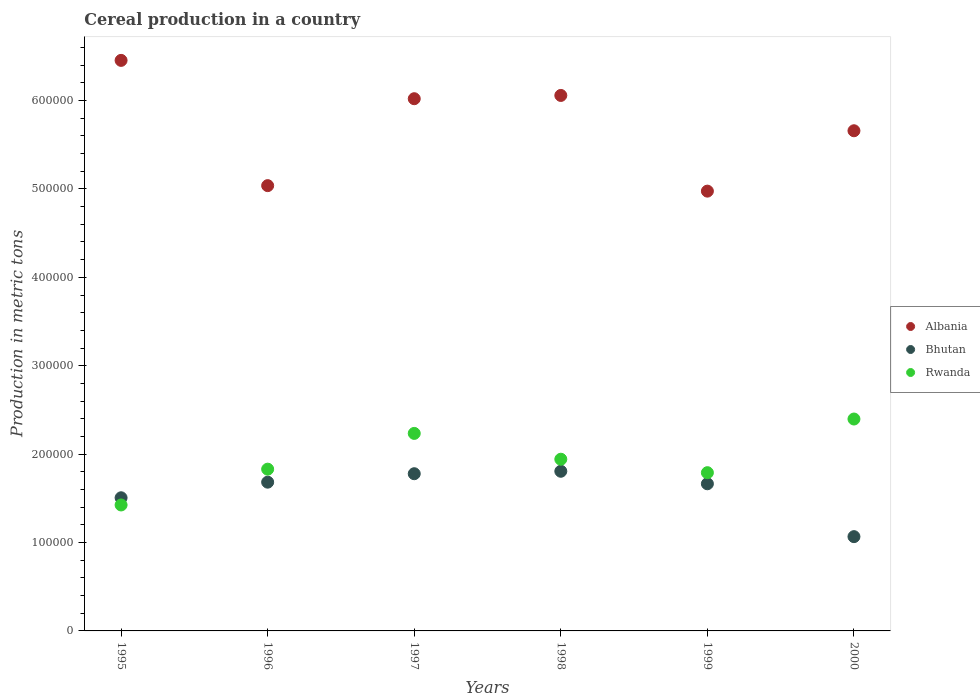What is the total cereal production in Bhutan in 1999?
Your answer should be very brief. 1.66e+05. Across all years, what is the maximum total cereal production in Rwanda?
Your response must be concise. 2.40e+05. Across all years, what is the minimum total cereal production in Bhutan?
Provide a short and direct response. 1.07e+05. In which year was the total cereal production in Bhutan minimum?
Keep it short and to the point. 2000. What is the total total cereal production in Bhutan in the graph?
Keep it short and to the point. 9.50e+05. What is the difference between the total cereal production in Rwanda in 1995 and that in 1998?
Offer a very short reply. -5.17e+04. What is the difference between the total cereal production in Albania in 1998 and the total cereal production in Rwanda in 1999?
Give a very brief answer. 4.27e+05. What is the average total cereal production in Albania per year?
Make the answer very short. 5.70e+05. In the year 1999, what is the difference between the total cereal production in Albania and total cereal production in Rwanda?
Make the answer very short. 3.18e+05. In how many years, is the total cereal production in Albania greater than 20000 metric tons?
Make the answer very short. 6. What is the ratio of the total cereal production in Albania in 1995 to that in 1997?
Offer a terse response. 1.07. What is the difference between the highest and the second highest total cereal production in Rwanda?
Your response must be concise. 1.63e+04. What is the difference between the highest and the lowest total cereal production in Rwanda?
Your response must be concise. 9.72e+04. In how many years, is the total cereal production in Rwanda greater than the average total cereal production in Rwanda taken over all years?
Offer a very short reply. 3. Does the total cereal production in Bhutan monotonically increase over the years?
Your answer should be very brief. No. Is the total cereal production in Rwanda strictly greater than the total cereal production in Albania over the years?
Your answer should be very brief. No. Is the total cereal production in Bhutan strictly less than the total cereal production in Albania over the years?
Provide a succinct answer. Yes. How many dotlines are there?
Make the answer very short. 3. How many years are there in the graph?
Ensure brevity in your answer.  6. What is the difference between two consecutive major ticks on the Y-axis?
Give a very brief answer. 1.00e+05. Are the values on the major ticks of Y-axis written in scientific E-notation?
Give a very brief answer. No. Does the graph contain grids?
Offer a terse response. No. Where does the legend appear in the graph?
Keep it short and to the point. Center right. How many legend labels are there?
Your answer should be very brief. 3. What is the title of the graph?
Ensure brevity in your answer.  Cereal production in a country. Does "High income: nonOECD" appear as one of the legend labels in the graph?
Keep it short and to the point. No. What is the label or title of the X-axis?
Your answer should be very brief. Years. What is the label or title of the Y-axis?
Make the answer very short. Production in metric tons. What is the Production in metric tons in Albania in 1995?
Make the answer very short. 6.45e+05. What is the Production in metric tons of Bhutan in 1995?
Keep it short and to the point. 1.51e+05. What is the Production in metric tons in Rwanda in 1995?
Your answer should be very brief. 1.42e+05. What is the Production in metric tons in Albania in 1996?
Provide a succinct answer. 5.04e+05. What is the Production in metric tons of Bhutan in 1996?
Offer a very short reply. 1.68e+05. What is the Production in metric tons of Rwanda in 1996?
Make the answer very short. 1.83e+05. What is the Production in metric tons of Albania in 1997?
Provide a short and direct response. 6.02e+05. What is the Production in metric tons of Bhutan in 1997?
Ensure brevity in your answer.  1.78e+05. What is the Production in metric tons in Rwanda in 1997?
Your answer should be compact. 2.23e+05. What is the Production in metric tons in Albania in 1998?
Ensure brevity in your answer.  6.06e+05. What is the Production in metric tons in Bhutan in 1998?
Provide a succinct answer. 1.81e+05. What is the Production in metric tons of Rwanda in 1998?
Make the answer very short. 1.94e+05. What is the Production in metric tons of Albania in 1999?
Keep it short and to the point. 4.98e+05. What is the Production in metric tons of Bhutan in 1999?
Provide a succinct answer. 1.66e+05. What is the Production in metric tons in Rwanda in 1999?
Make the answer very short. 1.79e+05. What is the Production in metric tons of Albania in 2000?
Provide a short and direct response. 5.66e+05. What is the Production in metric tons in Bhutan in 2000?
Your response must be concise. 1.07e+05. What is the Production in metric tons in Rwanda in 2000?
Your response must be concise. 2.40e+05. Across all years, what is the maximum Production in metric tons of Albania?
Provide a succinct answer. 6.45e+05. Across all years, what is the maximum Production in metric tons in Bhutan?
Offer a very short reply. 1.81e+05. Across all years, what is the maximum Production in metric tons of Rwanda?
Give a very brief answer. 2.40e+05. Across all years, what is the minimum Production in metric tons in Albania?
Offer a very short reply. 4.98e+05. Across all years, what is the minimum Production in metric tons in Bhutan?
Your response must be concise. 1.07e+05. Across all years, what is the minimum Production in metric tons of Rwanda?
Offer a terse response. 1.42e+05. What is the total Production in metric tons of Albania in the graph?
Your answer should be very brief. 3.42e+06. What is the total Production in metric tons in Bhutan in the graph?
Keep it short and to the point. 9.50e+05. What is the total Production in metric tons in Rwanda in the graph?
Your answer should be very brief. 1.16e+06. What is the difference between the Production in metric tons of Albania in 1995 and that in 1996?
Keep it short and to the point. 1.42e+05. What is the difference between the Production in metric tons of Bhutan in 1995 and that in 1996?
Offer a terse response. -1.76e+04. What is the difference between the Production in metric tons in Rwanda in 1995 and that in 1996?
Your response must be concise. -4.05e+04. What is the difference between the Production in metric tons in Albania in 1995 and that in 1997?
Your response must be concise. 4.34e+04. What is the difference between the Production in metric tons of Bhutan in 1995 and that in 1997?
Give a very brief answer. -2.72e+04. What is the difference between the Production in metric tons in Rwanda in 1995 and that in 1997?
Offer a terse response. -8.10e+04. What is the difference between the Production in metric tons of Albania in 1995 and that in 1998?
Offer a very short reply. 3.97e+04. What is the difference between the Production in metric tons in Bhutan in 1995 and that in 1998?
Give a very brief answer. -3.00e+04. What is the difference between the Production in metric tons of Rwanda in 1995 and that in 1998?
Offer a very short reply. -5.17e+04. What is the difference between the Production in metric tons of Albania in 1995 and that in 1999?
Make the answer very short. 1.48e+05. What is the difference between the Production in metric tons in Bhutan in 1995 and that in 1999?
Give a very brief answer. -1.58e+04. What is the difference between the Production in metric tons of Rwanda in 1995 and that in 1999?
Keep it short and to the point. -3.65e+04. What is the difference between the Production in metric tons of Albania in 1995 and that in 2000?
Provide a short and direct response. 7.96e+04. What is the difference between the Production in metric tons of Bhutan in 1995 and that in 2000?
Your answer should be compact. 4.40e+04. What is the difference between the Production in metric tons of Rwanda in 1995 and that in 2000?
Your answer should be compact. -9.72e+04. What is the difference between the Production in metric tons in Albania in 1996 and that in 1997?
Offer a terse response. -9.83e+04. What is the difference between the Production in metric tons in Bhutan in 1996 and that in 1997?
Offer a very short reply. -9560. What is the difference between the Production in metric tons of Rwanda in 1996 and that in 1997?
Keep it short and to the point. -4.05e+04. What is the difference between the Production in metric tons of Albania in 1996 and that in 1998?
Give a very brief answer. -1.02e+05. What is the difference between the Production in metric tons in Bhutan in 1996 and that in 1998?
Make the answer very short. -1.23e+04. What is the difference between the Production in metric tons of Rwanda in 1996 and that in 1998?
Give a very brief answer. -1.12e+04. What is the difference between the Production in metric tons of Albania in 1996 and that in 1999?
Your answer should be very brief. 6214. What is the difference between the Production in metric tons of Bhutan in 1996 and that in 1999?
Offer a terse response. 1817. What is the difference between the Production in metric tons of Rwanda in 1996 and that in 1999?
Your answer should be compact. 3975. What is the difference between the Production in metric tons of Albania in 1996 and that in 2000?
Offer a terse response. -6.21e+04. What is the difference between the Production in metric tons of Bhutan in 1996 and that in 2000?
Your answer should be compact. 6.16e+04. What is the difference between the Production in metric tons of Rwanda in 1996 and that in 2000?
Your answer should be compact. -5.67e+04. What is the difference between the Production in metric tons of Albania in 1997 and that in 1998?
Give a very brief answer. -3703. What is the difference between the Production in metric tons in Bhutan in 1997 and that in 1998?
Make the answer very short. -2772. What is the difference between the Production in metric tons in Rwanda in 1997 and that in 1998?
Offer a terse response. 2.92e+04. What is the difference between the Production in metric tons of Albania in 1997 and that in 1999?
Offer a very short reply. 1.05e+05. What is the difference between the Production in metric tons in Bhutan in 1997 and that in 1999?
Your response must be concise. 1.14e+04. What is the difference between the Production in metric tons of Rwanda in 1997 and that in 1999?
Provide a succinct answer. 4.44e+04. What is the difference between the Production in metric tons in Albania in 1997 and that in 2000?
Ensure brevity in your answer.  3.62e+04. What is the difference between the Production in metric tons in Bhutan in 1997 and that in 2000?
Give a very brief answer. 7.12e+04. What is the difference between the Production in metric tons in Rwanda in 1997 and that in 2000?
Make the answer very short. -1.63e+04. What is the difference between the Production in metric tons in Albania in 1998 and that in 1999?
Provide a short and direct response. 1.08e+05. What is the difference between the Production in metric tons of Bhutan in 1998 and that in 1999?
Your answer should be very brief. 1.41e+04. What is the difference between the Production in metric tons in Rwanda in 1998 and that in 1999?
Ensure brevity in your answer.  1.52e+04. What is the difference between the Production in metric tons of Albania in 1998 and that in 2000?
Provide a short and direct response. 3.99e+04. What is the difference between the Production in metric tons in Bhutan in 1998 and that in 2000?
Your response must be concise. 7.40e+04. What is the difference between the Production in metric tons in Rwanda in 1998 and that in 2000?
Your response must be concise. -4.55e+04. What is the difference between the Production in metric tons of Albania in 1999 and that in 2000?
Ensure brevity in your answer.  -6.83e+04. What is the difference between the Production in metric tons of Bhutan in 1999 and that in 2000?
Ensure brevity in your answer.  5.98e+04. What is the difference between the Production in metric tons of Rwanda in 1999 and that in 2000?
Keep it short and to the point. -6.07e+04. What is the difference between the Production in metric tons in Albania in 1995 and the Production in metric tons in Bhutan in 1996?
Offer a terse response. 4.77e+05. What is the difference between the Production in metric tons in Albania in 1995 and the Production in metric tons in Rwanda in 1996?
Your answer should be very brief. 4.62e+05. What is the difference between the Production in metric tons of Bhutan in 1995 and the Production in metric tons of Rwanda in 1996?
Ensure brevity in your answer.  -3.24e+04. What is the difference between the Production in metric tons in Albania in 1995 and the Production in metric tons in Bhutan in 1997?
Offer a terse response. 4.68e+05. What is the difference between the Production in metric tons of Albania in 1995 and the Production in metric tons of Rwanda in 1997?
Offer a terse response. 4.22e+05. What is the difference between the Production in metric tons in Bhutan in 1995 and the Production in metric tons in Rwanda in 1997?
Keep it short and to the point. -7.28e+04. What is the difference between the Production in metric tons of Albania in 1995 and the Production in metric tons of Bhutan in 1998?
Your answer should be very brief. 4.65e+05. What is the difference between the Production in metric tons of Albania in 1995 and the Production in metric tons of Rwanda in 1998?
Your answer should be compact. 4.51e+05. What is the difference between the Production in metric tons in Bhutan in 1995 and the Production in metric tons in Rwanda in 1998?
Offer a very short reply. -4.36e+04. What is the difference between the Production in metric tons in Albania in 1995 and the Production in metric tons in Bhutan in 1999?
Provide a short and direct response. 4.79e+05. What is the difference between the Production in metric tons of Albania in 1995 and the Production in metric tons of Rwanda in 1999?
Give a very brief answer. 4.66e+05. What is the difference between the Production in metric tons in Bhutan in 1995 and the Production in metric tons in Rwanda in 1999?
Make the answer very short. -2.84e+04. What is the difference between the Production in metric tons of Albania in 1995 and the Production in metric tons of Bhutan in 2000?
Make the answer very short. 5.39e+05. What is the difference between the Production in metric tons in Albania in 1995 and the Production in metric tons in Rwanda in 2000?
Provide a succinct answer. 4.06e+05. What is the difference between the Production in metric tons in Bhutan in 1995 and the Production in metric tons in Rwanda in 2000?
Ensure brevity in your answer.  -8.91e+04. What is the difference between the Production in metric tons in Albania in 1996 and the Production in metric tons in Bhutan in 1997?
Your response must be concise. 3.26e+05. What is the difference between the Production in metric tons in Albania in 1996 and the Production in metric tons in Rwanda in 1997?
Give a very brief answer. 2.80e+05. What is the difference between the Production in metric tons of Bhutan in 1996 and the Production in metric tons of Rwanda in 1997?
Make the answer very short. -5.52e+04. What is the difference between the Production in metric tons of Albania in 1996 and the Production in metric tons of Bhutan in 1998?
Offer a very short reply. 3.23e+05. What is the difference between the Production in metric tons in Albania in 1996 and the Production in metric tons in Rwanda in 1998?
Provide a succinct answer. 3.09e+05. What is the difference between the Production in metric tons of Bhutan in 1996 and the Production in metric tons of Rwanda in 1998?
Your response must be concise. -2.60e+04. What is the difference between the Production in metric tons in Albania in 1996 and the Production in metric tons in Bhutan in 1999?
Offer a terse response. 3.37e+05. What is the difference between the Production in metric tons in Albania in 1996 and the Production in metric tons in Rwanda in 1999?
Make the answer very short. 3.25e+05. What is the difference between the Production in metric tons in Bhutan in 1996 and the Production in metric tons in Rwanda in 1999?
Your answer should be very brief. -1.07e+04. What is the difference between the Production in metric tons in Albania in 1996 and the Production in metric tons in Bhutan in 2000?
Your response must be concise. 3.97e+05. What is the difference between the Production in metric tons of Albania in 1996 and the Production in metric tons of Rwanda in 2000?
Make the answer very short. 2.64e+05. What is the difference between the Production in metric tons of Bhutan in 1996 and the Production in metric tons of Rwanda in 2000?
Your response must be concise. -7.14e+04. What is the difference between the Production in metric tons in Albania in 1997 and the Production in metric tons in Bhutan in 1998?
Provide a succinct answer. 4.21e+05. What is the difference between the Production in metric tons of Albania in 1997 and the Production in metric tons of Rwanda in 1998?
Provide a succinct answer. 4.08e+05. What is the difference between the Production in metric tons in Bhutan in 1997 and the Production in metric tons in Rwanda in 1998?
Your answer should be very brief. -1.64e+04. What is the difference between the Production in metric tons of Albania in 1997 and the Production in metric tons of Bhutan in 1999?
Make the answer very short. 4.36e+05. What is the difference between the Production in metric tons of Albania in 1997 and the Production in metric tons of Rwanda in 1999?
Your response must be concise. 4.23e+05. What is the difference between the Production in metric tons in Bhutan in 1997 and the Production in metric tons in Rwanda in 1999?
Offer a terse response. -1173. What is the difference between the Production in metric tons in Albania in 1997 and the Production in metric tons in Bhutan in 2000?
Ensure brevity in your answer.  4.95e+05. What is the difference between the Production in metric tons of Albania in 1997 and the Production in metric tons of Rwanda in 2000?
Make the answer very short. 3.62e+05. What is the difference between the Production in metric tons in Bhutan in 1997 and the Production in metric tons in Rwanda in 2000?
Offer a very short reply. -6.19e+04. What is the difference between the Production in metric tons in Albania in 1998 and the Production in metric tons in Bhutan in 1999?
Your answer should be very brief. 4.39e+05. What is the difference between the Production in metric tons of Albania in 1998 and the Production in metric tons of Rwanda in 1999?
Give a very brief answer. 4.27e+05. What is the difference between the Production in metric tons in Bhutan in 1998 and the Production in metric tons in Rwanda in 1999?
Offer a very short reply. 1599. What is the difference between the Production in metric tons in Albania in 1998 and the Production in metric tons in Bhutan in 2000?
Your answer should be very brief. 4.99e+05. What is the difference between the Production in metric tons of Albania in 1998 and the Production in metric tons of Rwanda in 2000?
Offer a very short reply. 3.66e+05. What is the difference between the Production in metric tons in Bhutan in 1998 and the Production in metric tons in Rwanda in 2000?
Your response must be concise. -5.91e+04. What is the difference between the Production in metric tons of Albania in 1999 and the Production in metric tons of Bhutan in 2000?
Provide a succinct answer. 3.91e+05. What is the difference between the Production in metric tons in Albania in 1999 and the Production in metric tons in Rwanda in 2000?
Your response must be concise. 2.58e+05. What is the difference between the Production in metric tons of Bhutan in 1999 and the Production in metric tons of Rwanda in 2000?
Keep it short and to the point. -7.33e+04. What is the average Production in metric tons in Albania per year?
Give a very brief answer. 5.70e+05. What is the average Production in metric tons of Bhutan per year?
Your response must be concise. 1.58e+05. What is the average Production in metric tons of Rwanda per year?
Offer a terse response. 1.94e+05. In the year 1995, what is the difference between the Production in metric tons in Albania and Production in metric tons in Bhutan?
Provide a succinct answer. 4.95e+05. In the year 1995, what is the difference between the Production in metric tons of Albania and Production in metric tons of Rwanda?
Make the answer very short. 5.03e+05. In the year 1995, what is the difference between the Production in metric tons in Bhutan and Production in metric tons in Rwanda?
Your answer should be very brief. 8140. In the year 1996, what is the difference between the Production in metric tons in Albania and Production in metric tons in Bhutan?
Offer a very short reply. 3.35e+05. In the year 1996, what is the difference between the Production in metric tons in Albania and Production in metric tons in Rwanda?
Keep it short and to the point. 3.21e+05. In the year 1996, what is the difference between the Production in metric tons in Bhutan and Production in metric tons in Rwanda?
Provide a succinct answer. -1.47e+04. In the year 1997, what is the difference between the Production in metric tons of Albania and Production in metric tons of Bhutan?
Give a very brief answer. 4.24e+05. In the year 1997, what is the difference between the Production in metric tons in Albania and Production in metric tons in Rwanda?
Your answer should be compact. 3.79e+05. In the year 1997, what is the difference between the Production in metric tons in Bhutan and Production in metric tons in Rwanda?
Provide a succinct answer. -4.56e+04. In the year 1998, what is the difference between the Production in metric tons of Albania and Production in metric tons of Bhutan?
Keep it short and to the point. 4.25e+05. In the year 1998, what is the difference between the Production in metric tons of Albania and Production in metric tons of Rwanda?
Provide a short and direct response. 4.12e+05. In the year 1998, what is the difference between the Production in metric tons in Bhutan and Production in metric tons in Rwanda?
Ensure brevity in your answer.  -1.36e+04. In the year 1999, what is the difference between the Production in metric tons of Albania and Production in metric tons of Bhutan?
Your response must be concise. 3.31e+05. In the year 1999, what is the difference between the Production in metric tons in Albania and Production in metric tons in Rwanda?
Your answer should be compact. 3.18e+05. In the year 1999, what is the difference between the Production in metric tons of Bhutan and Production in metric tons of Rwanda?
Give a very brief answer. -1.26e+04. In the year 2000, what is the difference between the Production in metric tons in Albania and Production in metric tons in Bhutan?
Give a very brief answer. 4.59e+05. In the year 2000, what is the difference between the Production in metric tons of Albania and Production in metric tons of Rwanda?
Keep it short and to the point. 3.26e+05. In the year 2000, what is the difference between the Production in metric tons in Bhutan and Production in metric tons in Rwanda?
Keep it short and to the point. -1.33e+05. What is the ratio of the Production in metric tons of Albania in 1995 to that in 1996?
Provide a succinct answer. 1.28. What is the ratio of the Production in metric tons in Bhutan in 1995 to that in 1996?
Make the answer very short. 0.9. What is the ratio of the Production in metric tons of Rwanda in 1995 to that in 1996?
Your answer should be compact. 0.78. What is the ratio of the Production in metric tons of Albania in 1995 to that in 1997?
Your answer should be very brief. 1.07. What is the ratio of the Production in metric tons in Bhutan in 1995 to that in 1997?
Your response must be concise. 0.85. What is the ratio of the Production in metric tons in Rwanda in 1995 to that in 1997?
Your answer should be very brief. 0.64. What is the ratio of the Production in metric tons of Albania in 1995 to that in 1998?
Your response must be concise. 1.07. What is the ratio of the Production in metric tons of Bhutan in 1995 to that in 1998?
Provide a short and direct response. 0.83. What is the ratio of the Production in metric tons of Rwanda in 1995 to that in 1998?
Offer a very short reply. 0.73. What is the ratio of the Production in metric tons in Albania in 1995 to that in 1999?
Your answer should be compact. 1.3. What is the ratio of the Production in metric tons in Bhutan in 1995 to that in 1999?
Provide a short and direct response. 0.9. What is the ratio of the Production in metric tons in Rwanda in 1995 to that in 1999?
Your response must be concise. 0.8. What is the ratio of the Production in metric tons of Albania in 1995 to that in 2000?
Offer a terse response. 1.14. What is the ratio of the Production in metric tons of Bhutan in 1995 to that in 2000?
Offer a very short reply. 1.41. What is the ratio of the Production in metric tons of Rwanda in 1995 to that in 2000?
Provide a succinct answer. 0.59. What is the ratio of the Production in metric tons of Albania in 1996 to that in 1997?
Make the answer very short. 0.84. What is the ratio of the Production in metric tons in Bhutan in 1996 to that in 1997?
Offer a very short reply. 0.95. What is the ratio of the Production in metric tons in Rwanda in 1996 to that in 1997?
Your answer should be very brief. 0.82. What is the ratio of the Production in metric tons of Albania in 1996 to that in 1998?
Your answer should be very brief. 0.83. What is the ratio of the Production in metric tons of Bhutan in 1996 to that in 1998?
Ensure brevity in your answer.  0.93. What is the ratio of the Production in metric tons of Rwanda in 1996 to that in 1998?
Keep it short and to the point. 0.94. What is the ratio of the Production in metric tons in Albania in 1996 to that in 1999?
Ensure brevity in your answer.  1.01. What is the ratio of the Production in metric tons in Bhutan in 1996 to that in 1999?
Provide a short and direct response. 1.01. What is the ratio of the Production in metric tons of Rwanda in 1996 to that in 1999?
Provide a short and direct response. 1.02. What is the ratio of the Production in metric tons of Albania in 1996 to that in 2000?
Give a very brief answer. 0.89. What is the ratio of the Production in metric tons of Bhutan in 1996 to that in 2000?
Your answer should be compact. 1.58. What is the ratio of the Production in metric tons of Rwanda in 1996 to that in 2000?
Your answer should be compact. 0.76. What is the ratio of the Production in metric tons of Bhutan in 1997 to that in 1998?
Offer a very short reply. 0.98. What is the ratio of the Production in metric tons in Rwanda in 1997 to that in 1998?
Ensure brevity in your answer.  1.15. What is the ratio of the Production in metric tons in Albania in 1997 to that in 1999?
Give a very brief answer. 1.21. What is the ratio of the Production in metric tons of Bhutan in 1997 to that in 1999?
Keep it short and to the point. 1.07. What is the ratio of the Production in metric tons of Rwanda in 1997 to that in 1999?
Your response must be concise. 1.25. What is the ratio of the Production in metric tons of Albania in 1997 to that in 2000?
Your answer should be very brief. 1.06. What is the ratio of the Production in metric tons in Bhutan in 1997 to that in 2000?
Provide a succinct answer. 1.67. What is the ratio of the Production in metric tons in Rwanda in 1997 to that in 2000?
Your answer should be compact. 0.93. What is the ratio of the Production in metric tons of Albania in 1998 to that in 1999?
Provide a succinct answer. 1.22. What is the ratio of the Production in metric tons of Bhutan in 1998 to that in 1999?
Keep it short and to the point. 1.08. What is the ratio of the Production in metric tons of Rwanda in 1998 to that in 1999?
Keep it short and to the point. 1.08. What is the ratio of the Production in metric tons in Albania in 1998 to that in 2000?
Provide a short and direct response. 1.07. What is the ratio of the Production in metric tons in Bhutan in 1998 to that in 2000?
Your answer should be very brief. 1.69. What is the ratio of the Production in metric tons in Rwanda in 1998 to that in 2000?
Ensure brevity in your answer.  0.81. What is the ratio of the Production in metric tons in Albania in 1999 to that in 2000?
Your answer should be very brief. 0.88. What is the ratio of the Production in metric tons in Bhutan in 1999 to that in 2000?
Give a very brief answer. 1.56. What is the ratio of the Production in metric tons in Rwanda in 1999 to that in 2000?
Your response must be concise. 0.75. What is the difference between the highest and the second highest Production in metric tons in Albania?
Offer a terse response. 3.97e+04. What is the difference between the highest and the second highest Production in metric tons in Bhutan?
Offer a terse response. 2772. What is the difference between the highest and the second highest Production in metric tons of Rwanda?
Provide a short and direct response. 1.63e+04. What is the difference between the highest and the lowest Production in metric tons of Albania?
Your answer should be compact. 1.48e+05. What is the difference between the highest and the lowest Production in metric tons in Bhutan?
Provide a short and direct response. 7.40e+04. What is the difference between the highest and the lowest Production in metric tons of Rwanda?
Offer a terse response. 9.72e+04. 